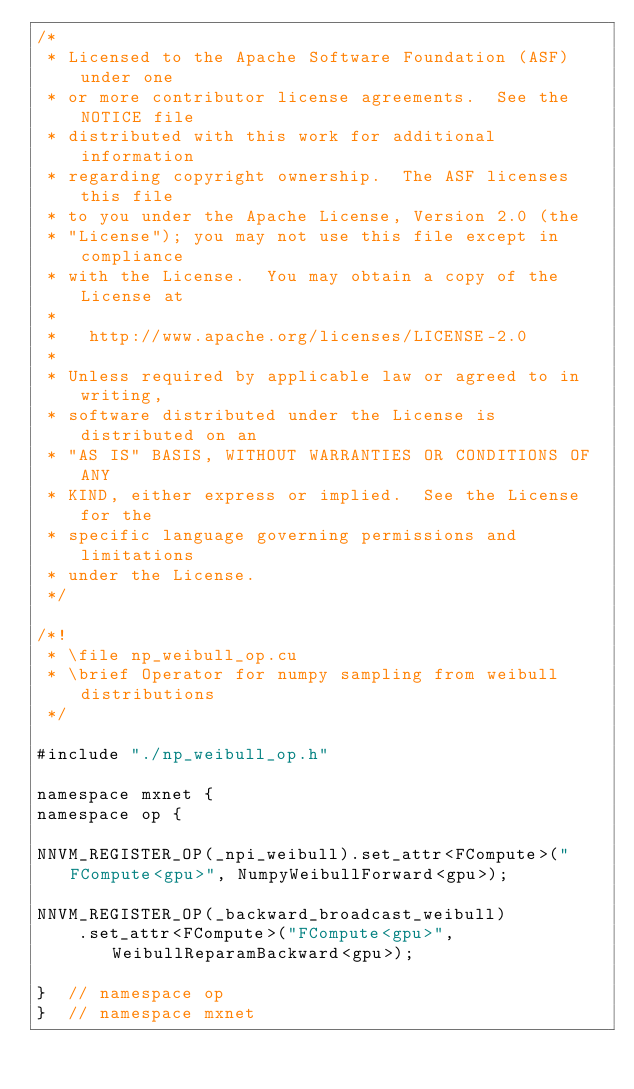<code> <loc_0><loc_0><loc_500><loc_500><_Cuda_>/*
 * Licensed to the Apache Software Foundation (ASF) under one
 * or more contributor license agreements.  See the NOTICE file
 * distributed with this work for additional information
 * regarding copyright ownership.  The ASF licenses this file
 * to you under the Apache License, Version 2.0 (the
 * "License"); you may not use this file except in compliance
 * with the License.  You may obtain a copy of the License at
 *
 *   http://www.apache.org/licenses/LICENSE-2.0
 *
 * Unless required by applicable law or agreed to in writing,
 * software distributed under the License is distributed on an
 * "AS IS" BASIS, WITHOUT WARRANTIES OR CONDITIONS OF ANY
 * KIND, either express or implied.  See the License for the
 * specific language governing permissions and limitations
 * under the License.
 */

/*!
 * \file np_weibull_op.cu
 * \brief Operator for numpy sampling from weibull distributions
 */

#include "./np_weibull_op.h"

namespace mxnet {
namespace op {

NNVM_REGISTER_OP(_npi_weibull).set_attr<FCompute>("FCompute<gpu>", NumpyWeibullForward<gpu>);

NNVM_REGISTER_OP(_backward_broadcast_weibull)
    .set_attr<FCompute>("FCompute<gpu>", WeibullReparamBackward<gpu>);

}  // namespace op
}  // namespace mxnet
</code> 